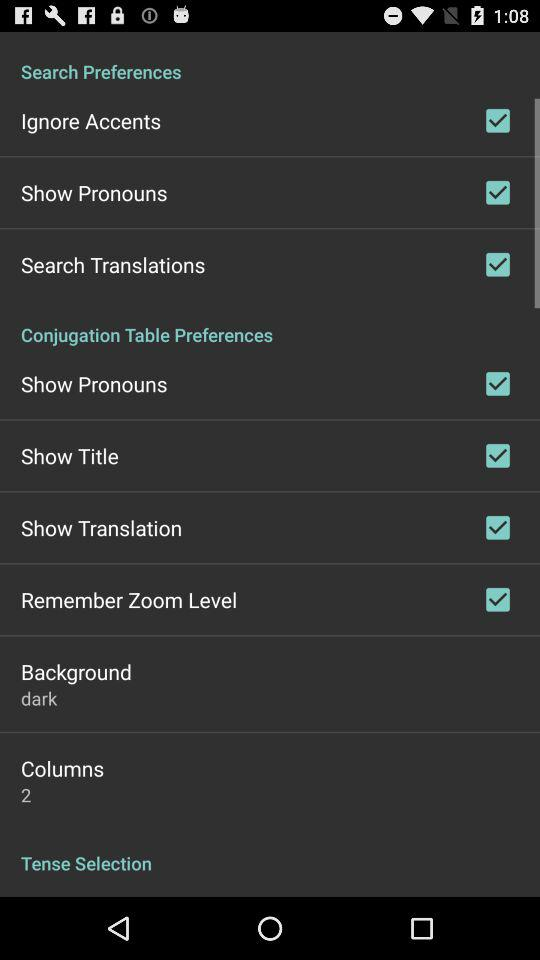What is the status of "Search Translations"? The status of "Search Translations" is "on". 